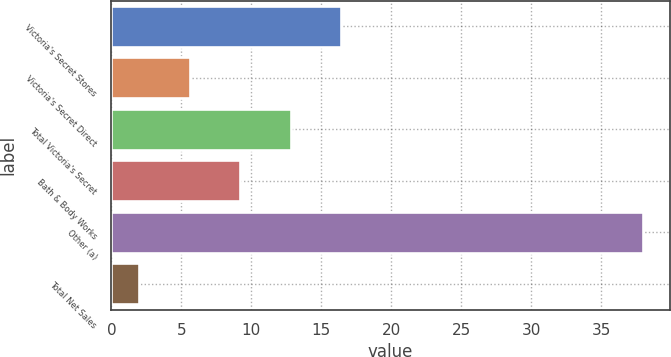Convert chart. <chart><loc_0><loc_0><loc_500><loc_500><bar_chart><fcel>Victoria's Secret Stores<fcel>Victoria's Secret Direct<fcel>Total Victoria's Secret<fcel>Bath & Body Works<fcel>Other (a)<fcel>Total Net Sales<nl><fcel>16.4<fcel>5.6<fcel>12.8<fcel>9.2<fcel>38<fcel>2<nl></chart> 